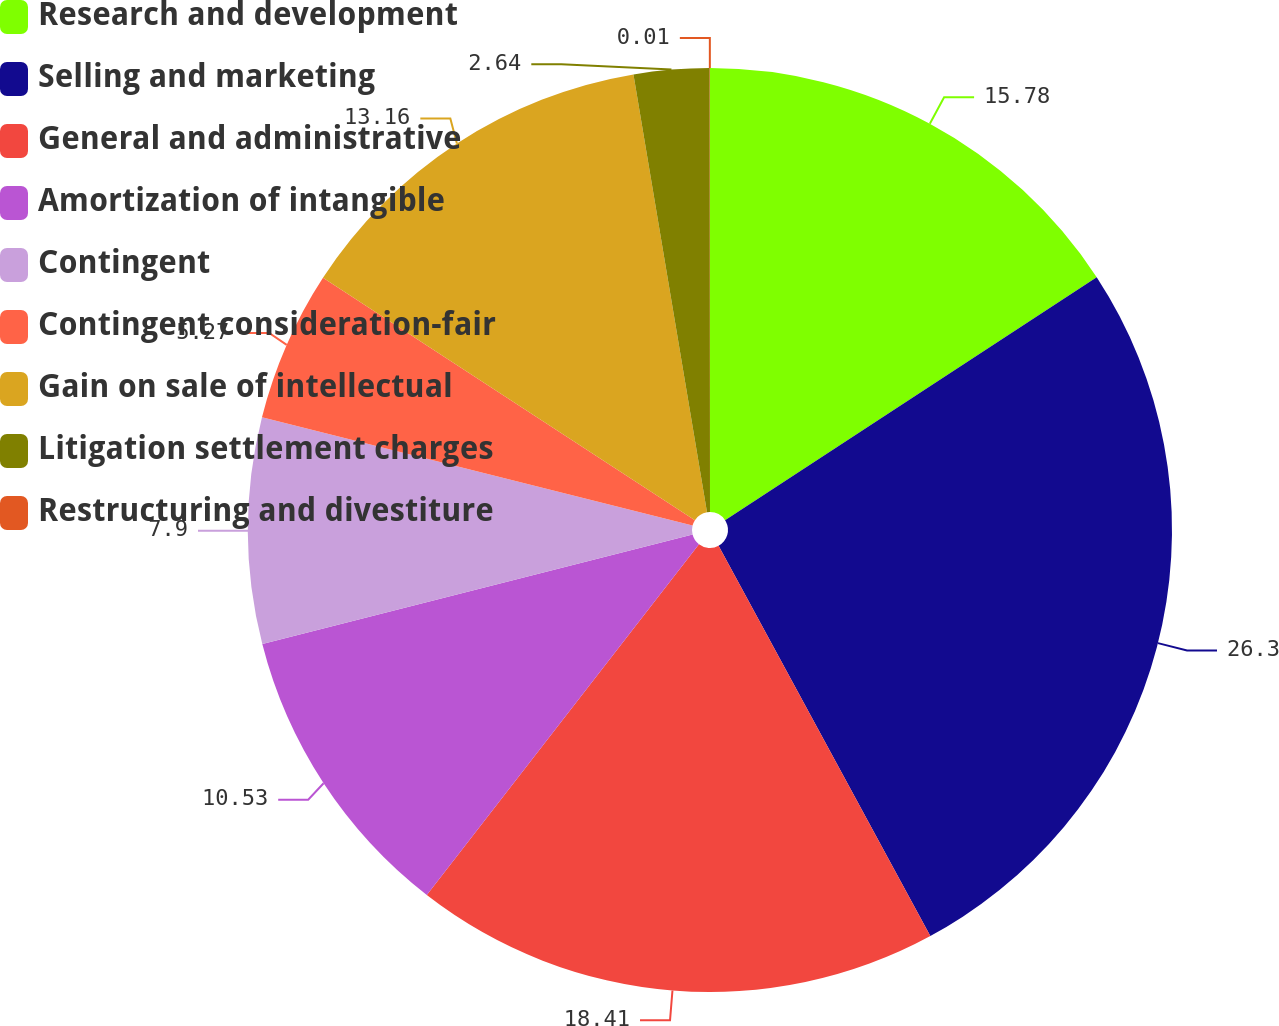Convert chart. <chart><loc_0><loc_0><loc_500><loc_500><pie_chart><fcel>Research and development<fcel>Selling and marketing<fcel>General and administrative<fcel>Amortization of intangible<fcel>Contingent<fcel>Contingent consideration-fair<fcel>Gain on sale of intellectual<fcel>Litigation settlement charges<fcel>Restructuring and divestiture<nl><fcel>15.79%<fcel>26.31%<fcel>18.42%<fcel>10.53%<fcel>7.9%<fcel>5.27%<fcel>13.16%<fcel>2.64%<fcel>0.01%<nl></chart> 